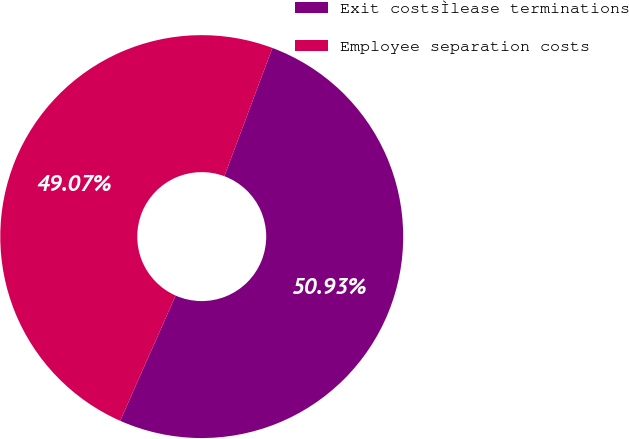Convert chart to OTSL. <chart><loc_0><loc_0><loc_500><loc_500><pie_chart><fcel>Exit costsÌlease terminations<fcel>Employee separation costs<nl><fcel>50.93%<fcel>49.07%<nl></chart> 